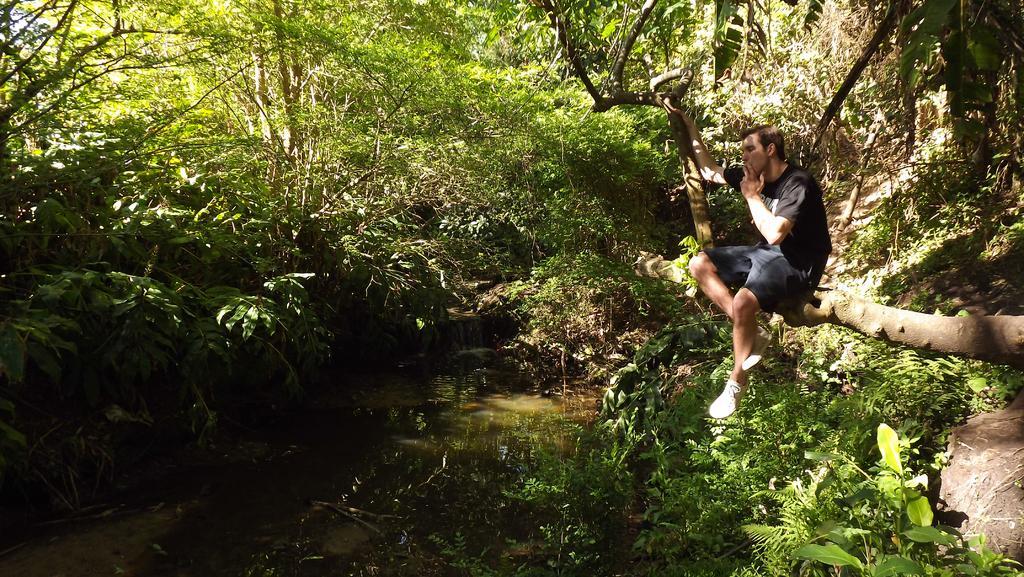Can you describe this image briefly? In this picture there is a man who is sitting on the tree branch. He is wearing t-shirt, short and shoe. He is smoking. At the bottom i can see the water and plants. In the background i can see many trees. In the top left corner there is a sky. 